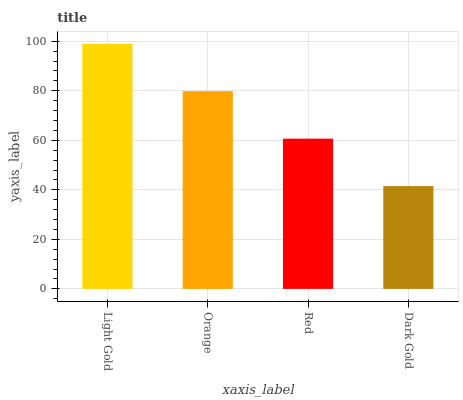Is Dark Gold the minimum?
Answer yes or no. Yes. Is Light Gold the maximum?
Answer yes or no. Yes. Is Orange the minimum?
Answer yes or no. No. Is Orange the maximum?
Answer yes or no. No. Is Light Gold greater than Orange?
Answer yes or no. Yes. Is Orange less than Light Gold?
Answer yes or no. Yes. Is Orange greater than Light Gold?
Answer yes or no. No. Is Light Gold less than Orange?
Answer yes or no. No. Is Orange the high median?
Answer yes or no. Yes. Is Red the low median?
Answer yes or no. Yes. Is Dark Gold the high median?
Answer yes or no. No. Is Dark Gold the low median?
Answer yes or no. No. 